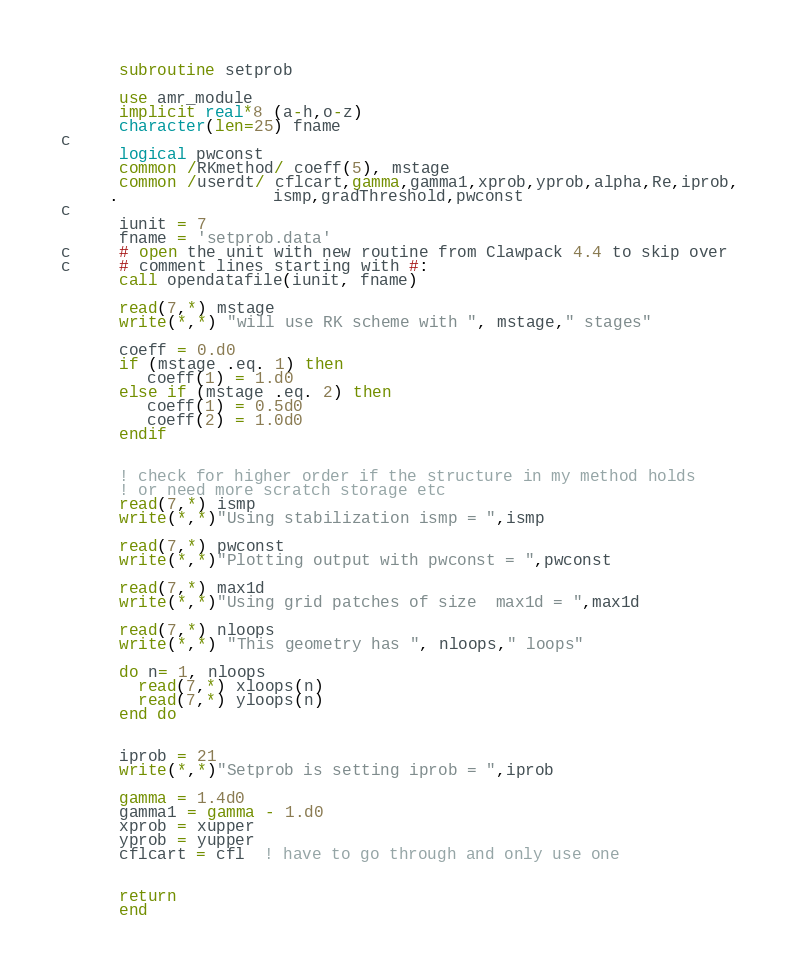Convert code to text. <code><loc_0><loc_0><loc_500><loc_500><_FORTRAN_>      subroutine setprob

      use amr_module
      implicit real*8 (a-h,o-z)
      character(len=25) fname
c
      logical pwconst
      common /RKmethod/ coeff(5), mstage
      common /userdt/ cflcart,gamma,gamma1,xprob,yprob,alpha,Re,iprob,
     .                ismp,gradThreshold,pwconst
c
      iunit = 7
      fname = 'setprob.data'
c     # open the unit with new routine from Clawpack 4.4 to skip over
c     # comment lines starting with #:
      call opendatafile(iunit, fname)

      read(7,*) mstage
      write(*,*) "will use RK scheme with ", mstage," stages"

      coeff = 0.d0 
      if (mstage .eq. 1) then
         coeff(1) = 1.d0
      else if (mstage .eq. 2) then
         coeff(1) = 0.5d0
         coeff(2) = 1.0d0
      endif


      ! check for higher order if the structure in my method holds
      ! or need more scratch storage etc
      read(7,*) ismp
      write(*,*)"Using stabilization ismp = ",ismp

      read(7,*) pwconst
      write(*,*)"Plotting output with pwconst = ",pwconst

      read(7,*) max1d
      write(*,*)"Using grid patches of size  max1d = ",max1d

      read(7,*) nloops
      write(*,*) "This geometry has ", nloops," loops"

      do n= 1, nloops
        read(7,*) xloops(n)
        read(7,*) yloops(n)
      end do


      iprob = 21
      write(*,*)"Setprob is setting iprob = ",iprob

      gamma = 1.4d0
      gamma1 = gamma - 1.d0
      xprob = xupper
      yprob = yupper
      cflcart = cfl  ! have to go through and only use one


      return
      end
</code> 